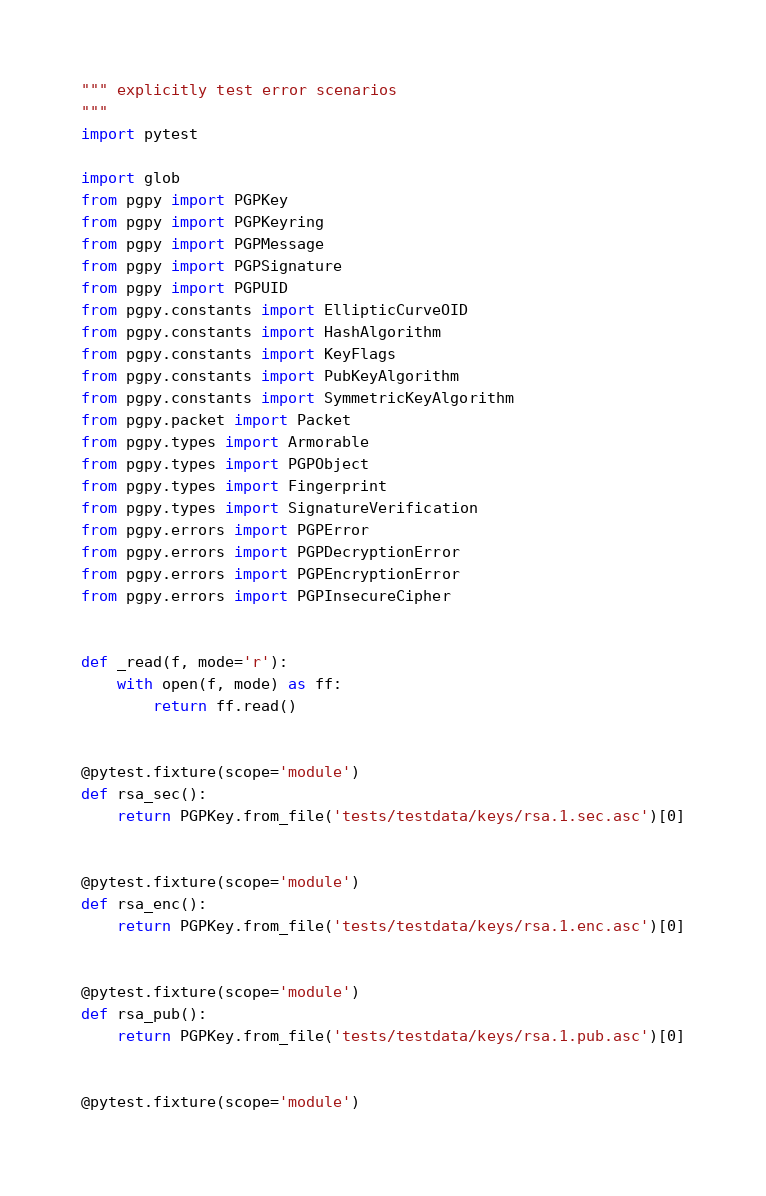<code> <loc_0><loc_0><loc_500><loc_500><_Python_>""" explicitly test error scenarios
"""
import pytest

import glob
from pgpy import PGPKey
from pgpy import PGPKeyring
from pgpy import PGPMessage
from pgpy import PGPSignature
from pgpy import PGPUID
from pgpy.constants import EllipticCurveOID
from pgpy.constants import HashAlgorithm
from pgpy.constants import KeyFlags
from pgpy.constants import PubKeyAlgorithm
from pgpy.constants import SymmetricKeyAlgorithm
from pgpy.packet import Packet
from pgpy.types import Armorable
from pgpy.types import PGPObject
from pgpy.types import Fingerprint
from pgpy.types import SignatureVerification
from pgpy.errors import PGPError
from pgpy.errors import PGPDecryptionError
from pgpy.errors import PGPEncryptionError
from pgpy.errors import PGPInsecureCipher


def _read(f, mode='r'):
    with open(f, mode) as ff:
        return ff.read()


@pytest.fixture(scope='module')
def rsa_sec():
    return PGPKey.from_file('tests/testdata/keys/rsa.1.sec.asc')[0]


@pytest.fixture(scope='module')
def rsa_enc():
    return PGPKey.from_file('tests/testdata/keys/rsa.1.enc.asc')[0]


@pytest.fixture(scope='module')
def rsa_pub():
    return PGPKey.from_file('tests/testdata/keys/rsa.1.pub.asc')[0]


@pytest.fixture(scope='module')</code> 